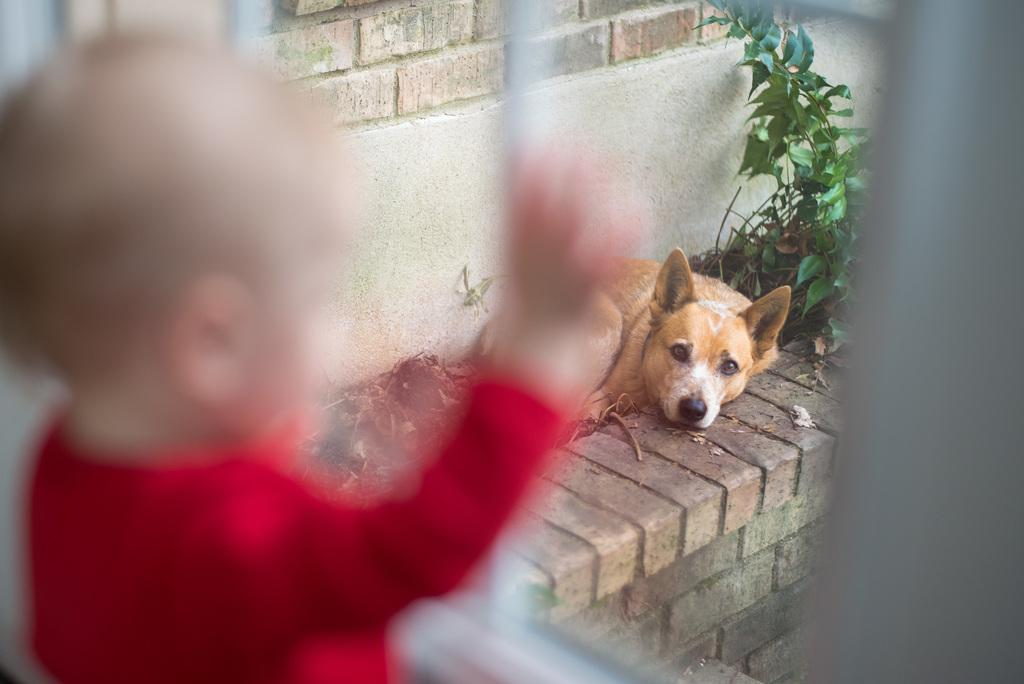What animal can be seen in the image? There is a dog in the image. What is the dog doing in the image? The dog is laying down. What is located behind the dog in the image? There is a plant behind the dog. Who or what is on the left side of the image? There is a kid on the left side of the image. What can be seen in the background of the image? There is a wall in the background of the image. What type of rock is the dog using as a pillow in the image? There is no rock present in the image, and the dog is not using any object as a pillow. 